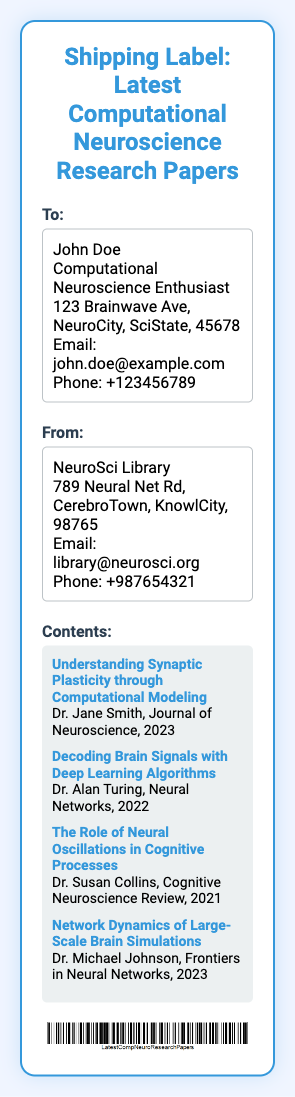What is the name of the recipient? The recipient's name is listed under the "To:" section of the shipping label.
Answer: John Doe What is the title of the first paper listed? The title of the first paper is in bold and followed by the author and journal.
Answer: Understanding Synaptic Plasticity through Computational Modeling Who is the author of the paper on decoding brain signals? The author's name comes after the paper title in the contents section.
Answer: Dr. Alan Turing What year was the paper "The Role of Neural Oscillations in Cognitive Processes" published? The publication year is mentioned after the author and journal in the contents section.
Answer: 2021 What is the phone number of the sender? The sender's phone number is provided in the "From:" section of the shipping label.
Answer: +987654321 How many research papers are listed on the shipping label? The number of papers can be counted in the contents section of the document.
Answer: Four Where is the sender's library located? The library's address is provided in the "From:" section.
Answer: 789 Neural Net Rd, CerebroTown, KnowlCity, 98765 What is the purpose of this document? This document is a shipping label, which indicates its function and content type.
Answer: Shipping label 